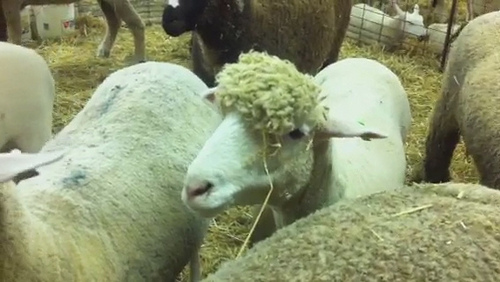What realistic scenarios might explain the gathered sheep in the image, one short and one long? Short: The sheep are gathered in the pen for their regular feeding time, enjoying the fresh hay that has just been laid out. Long: The scene in the image depicts a typical day on a well-maintained farm. The sheep have been herded into the pen for their afternoon feeding. The farmer has just replenished the straw bedding and scattered a fresh supply of hay, attracting the sheep to gather closely. Some are busy eating, while others stand around, savoring the community activity. The pen ensures the sheep are safe, comfortable, and well-fed, under the constant supervision of the attentive farm staff. This arrangement is part of the farm's daily routine, ensuring the health and happiness of the flock. 